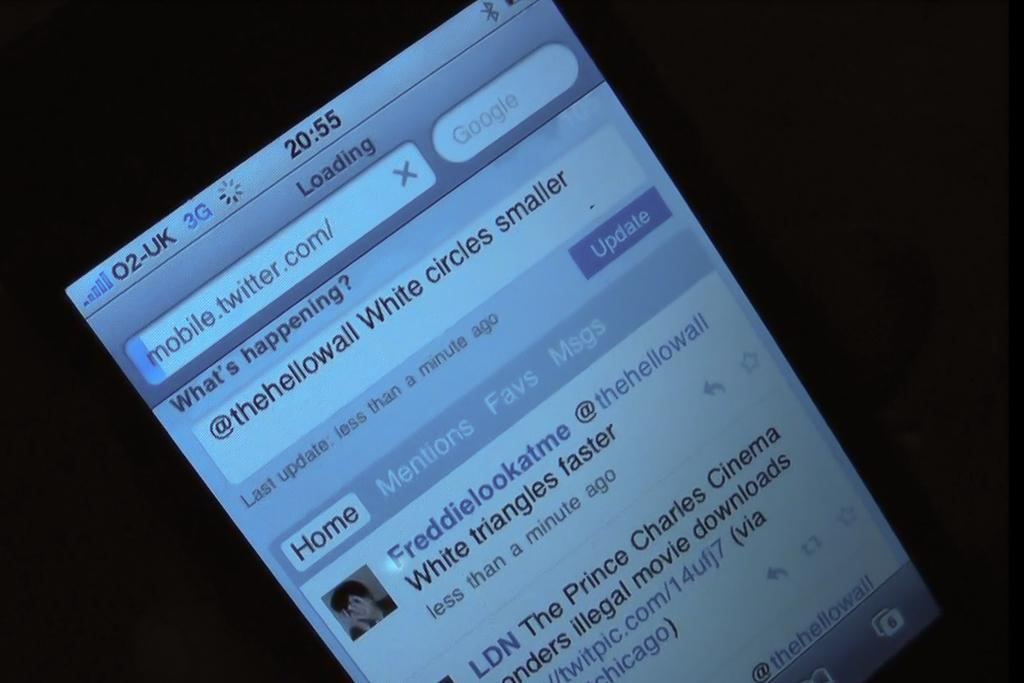<image>
Relay a brief, clear account of the picture shown. Someone is looking at Twitter on their cell phone at 20:55. 